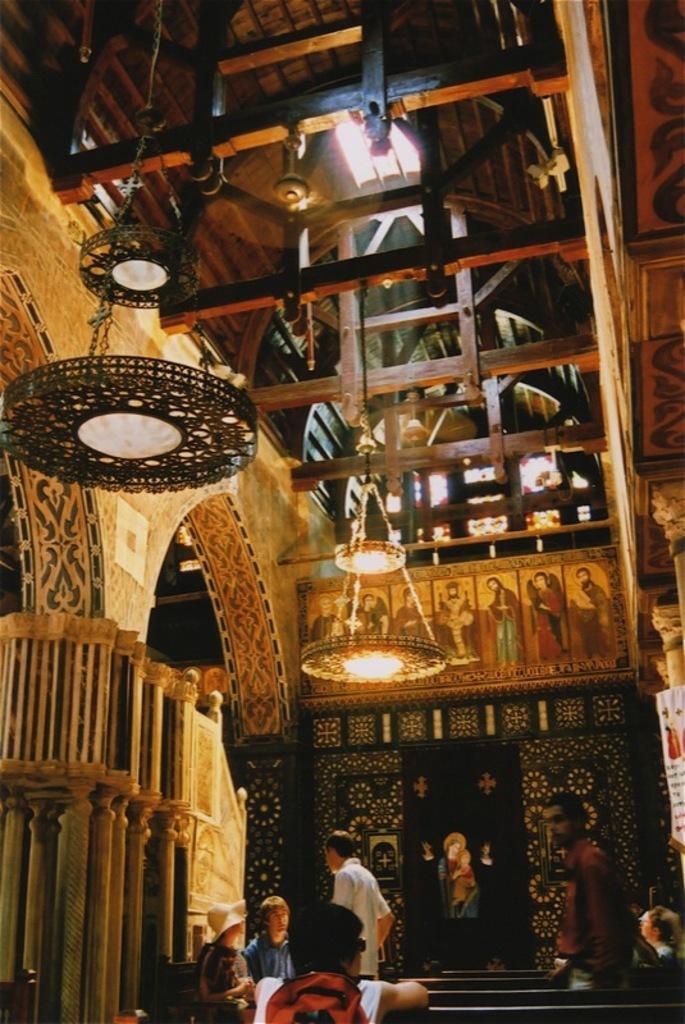In one or two sentences, can you explain what this image depicts? In this picture we can see a group of people, benches and some objects. At the top, lights are hanging. 